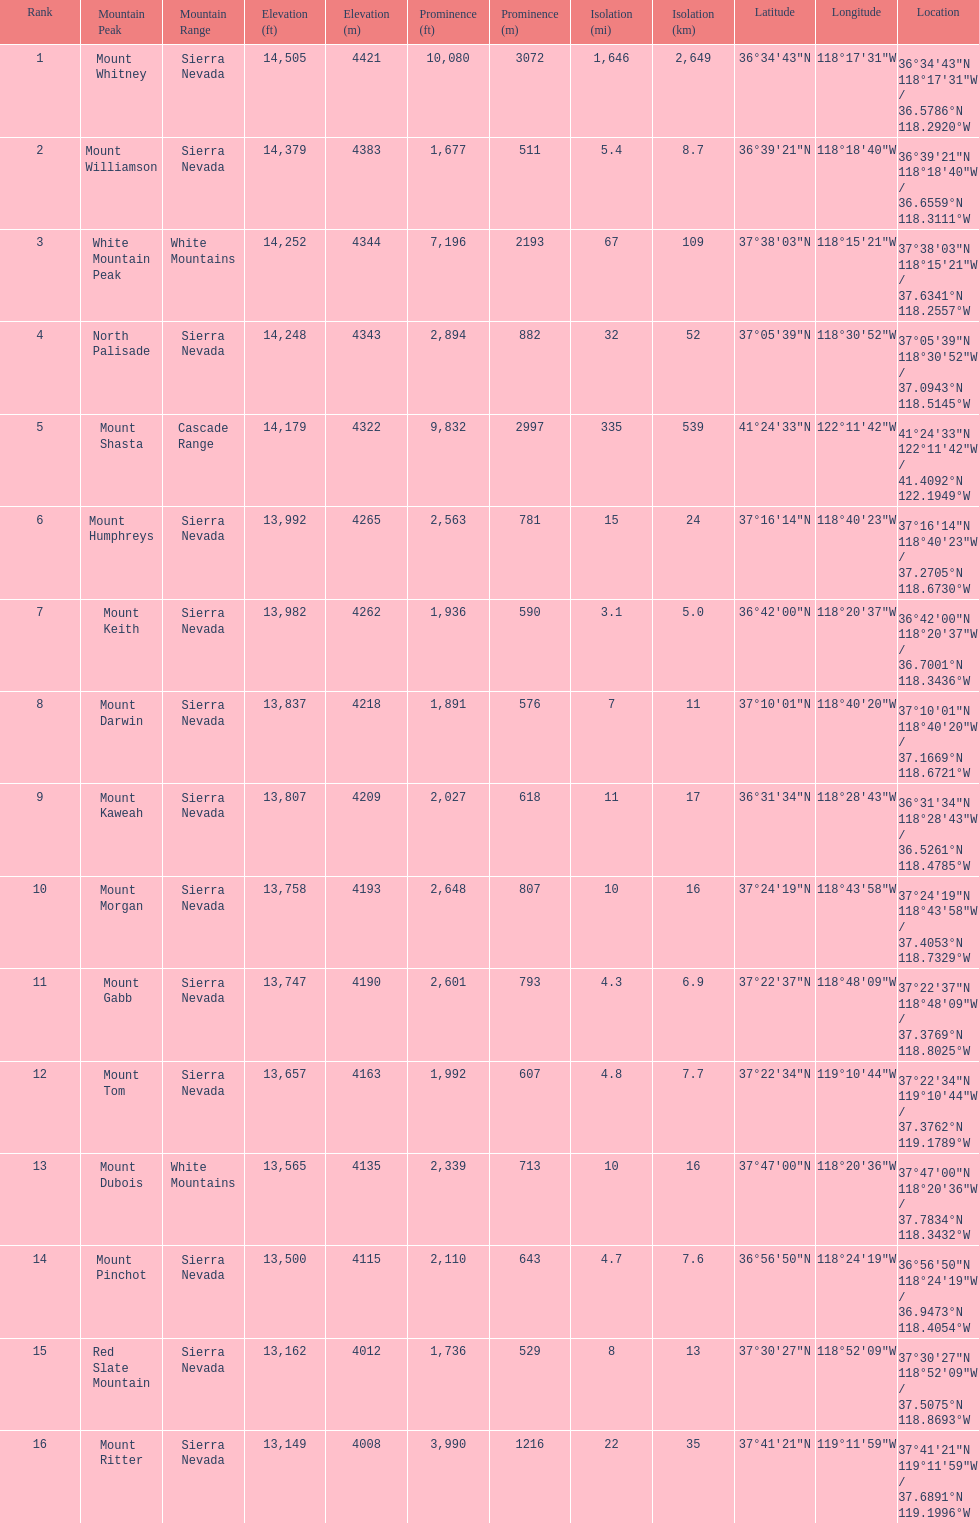Which mountain peak has the least isolation? Mount Keith. 